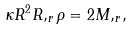Convert formula to latex. <formula><loc_0><loc_0><loc_500><loc_500>\kappa R ^ { 2 } R , _ { r } \rho = 2 { M , _ { r } } ,</formula> 